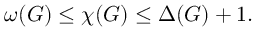Convert formula to latex. <formula><loc_0><loc_0><loc_500><loc_500>\omega ( G ) \leq \chi ( G ) \leq \Delta ( G ) + 1 .</formula> 